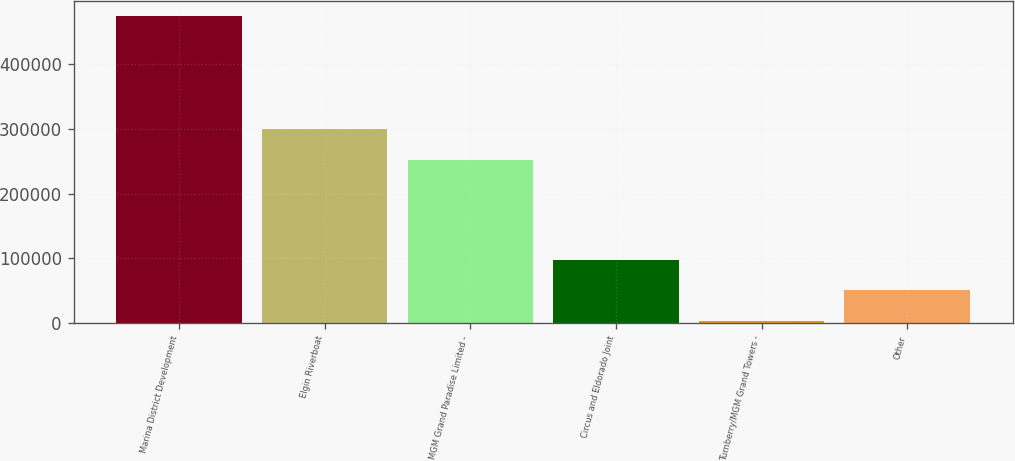Convert chart to OTSL. <chart><loc_0><loc_0><loc_500><loc_500><bar_chart><fcel>Marina District Development<fcel>Elgin Riverboat<fcel>MGM Grand Paradise Limited -<fcel>Circus and Eldorado Joint<fcel>Turnberry/MGM Grand Towers -<fcel>Other<nl><fcel>474171<fcel>299146<fcel>252060<fcel>97481.4<fcel>3309<fcel>50395.2<nl></chart> 